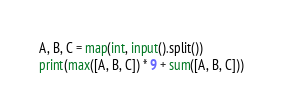<code> <loc_0><loc_0><loc_500><loc_500><_Python_>A, B, C = map(int, input().split())
print(max([A, B, C]) * 9 + sum([A, B, C]))
</code> 